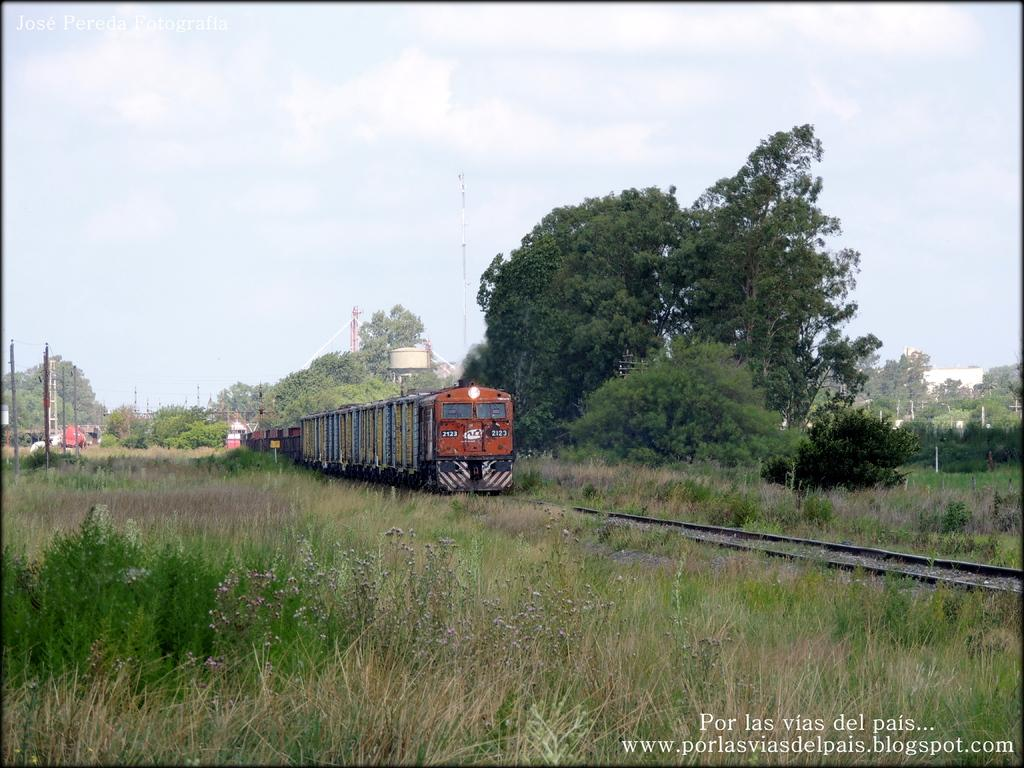What type of vegetation can be seen in the image? There is grass in the image. What other natural elements are present in the image? There are trees in the image. What man-made structure is visible in the image? There is a train in the image. What is the train traveling on? There is a railway track in the image. What are the current poles used for? The current poles are used for providing electricity to the train. What is visible in the background of the image? The sky is visible in the image. What type of creature is causing destruction to the train in the image? There is no creature present in the image, nor is there any destruction occurring to the train. 